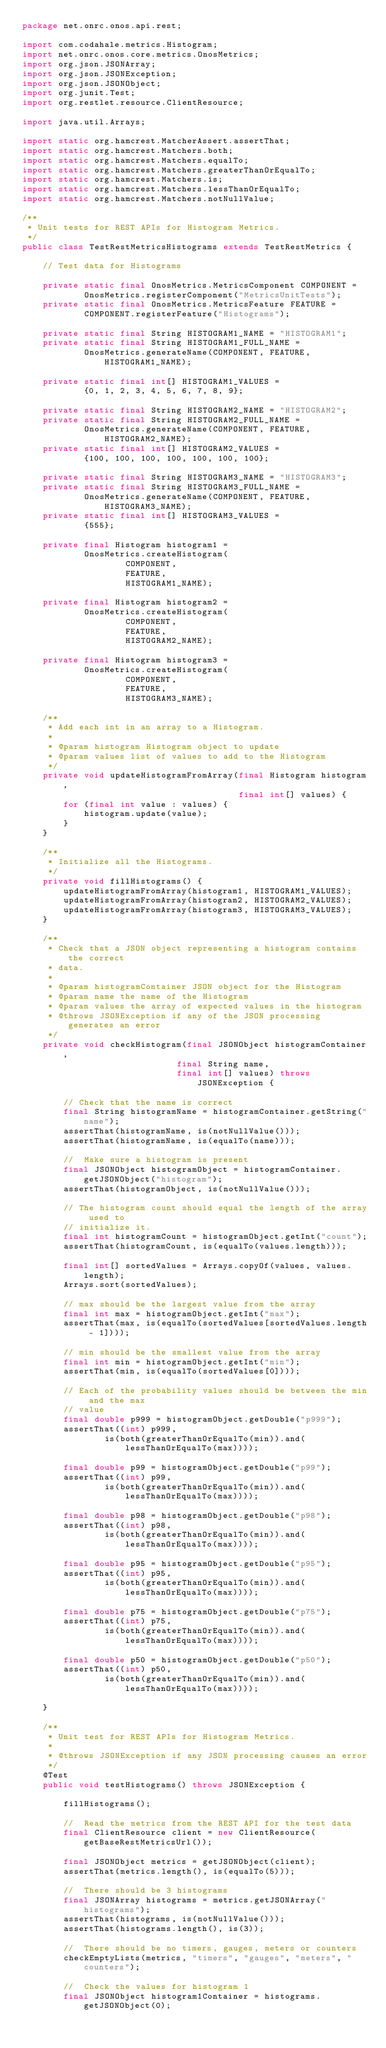<code> <loc_0><loc_0><loc_500><loc_500><_Java_>package net.onrc.onos.api.rest;

import com.codahale.metrics.Histogram;
import net.onrc.onos.core.metrics.OnosMetrics;
import org.json.JSONArray;
import org.json.JSONException;
import org.json.JSONObject;
import org.junit.Test;
import org.restlet.resource.ClientResource;

import java.util.Arrays;

import static org.hamcrest.MatcherAssert.assertThat;
import static org.hamcrest.Matchers.both;
import static org.hamcrest.Matchers.equalTo;
import static org.hamcrest.Matchers.greaterThanOrEqualTo;
import static org.hamcrest.Matchers.is;
import static org.hamcrest.Matchers.lessThanOrEqualTo;
import static org.hamcrest.Matchers.notNullValue;

/**
 * Unit tests for REST APIs for Histogram Metrics.
 */
public class TestRestMetricsHistograms extends TestRestMetrics {

    // Test data for Histograms

    private static final OnosMetrics.MetricsComponent COMPONENT =
            OnosMetrics.registerComponent("MetricsUnitTests");
    private static final OnosMetrics.MetricsFeature FEATURE =
            COMPONENT.registerFeature("Histograms");

    private static final String HISTOGRAM1_NAME = "HISTOGRAM1";
    private static final String HISTOGRAM1_FULL_NAME =
            OnosMetrics.generateName(COMPONENT, FEATURE, HISTOGRAM1_NAME);

    private static final int[] HISTOGRAM1_VALUES =
            {0, 1, 2, 3, 4, 5, 6, 7, 8, 9};

    private static final String HISTOGRAM2_NAME = "HISTOGRAM2";
    private static final String HISTOGRAM2_FULL_NAME =
            OnosMetrics.generateName(COMPONENT, FEATURE, HISTOGRAM2_NAME);
    private static final int[] HISTOGRAM2_VALUES =
            {100, 100, 100, 100, 100, 100, 100};

    private static final String HISTOGRAM3_NAME = "HISTOGRAM3";
    private static final String HISTOGRAM3_FULL_NAME =
            OnosMetrics.generateName(COMPONENT, FEATURE, HISTOGRAM3_NAME);
    private static final int[] HISTOGRAM3_VALUES =
            {555};

    private final Histogram histogram1 =
            OnosMetrics.createHistogram(
                    COMPONENT,
                    FEATURE,
                    HISTOGRAM1_NAME);

    private final Histogram histogram2 =
            OnosMetrics.createHistogram(
                    COMPONENT,
                    FEATURE,
                    HISTOGRAM2_NAME);

    private final Histogram histogram3 =
            OnosMetrics.createHistogram(
                    COMPONENT,
                    FEATURE,
                    HISTOGRAM3_NAME);

    /**
     * Add each int in an array to a Histogram.
     *
     * @param histogram Histogram object to update
     * @param values list of values to add to the Histogram
     */
    private void updateHistogramFromArray(final Histogram histogram,
                                          final int[] values) {
        for (final int value : values) {
            histogram.update(value);
        }
    }

    /**
     * Initialize all the Histograms.
     */
    private void fillHistograms() {
        updateHistogramFromArray(histogram1, HISTOGRAM1_VALUES);
        updateHistogramFromArray(histogram2, HISTOGRAM2_VALUES);
        updateHistogramFromArray(histogram3, HISTOGRAM3_VALUES);
    }

    /**
     * Check that a JSON object representing a histogram contains the correct
     * data.
     *
     * @param histogramContainer JSON object for the Histogram
     * @param name the name of the Histogram
     * @param values the array of expected values in the histogram
     * @throws JSONException if any of the JSON processing generates an error
     */
    private void checkHistogram(final JSONObject histogramContainer,
                              final String name,
                              final int[] values) throws JSONException {

        // Check that the name is correct
        final String histogramName = histogramContainer.getString("name");
        assertThat(histogramName, is(notNullValue()));
        assertThat(histogramName, is(equalTo(name)));

        //  Make sure a histogram is present
        final JSONObject histogramObject = histogramContainer.getJSONObject("histogram");
        assertThat(histogramObject, is(notNullValue()));

        // The histogram count should equal the length of the array used to
        // initialize it.
        final int histogramCount = histogramObject.getInt("count");
        assertThat(histogramCount, is(equalTo(values.length)));

        final int[] sortedValues = Arrays.copyOf(values, values.length);
        Arrays.sort(sortedValues);

        // max should be the largest value from the array
        final int max = histogramObject.getInt("max");
        assertThat(max, is(equalTo(sortedValues[sortedValues.length - 1])));

        // min should be the smallest value from the array
        final int min = histogramObject.getInt("min");
        assertThat(min, is(equalTo(sortedValues[0])));

        // Each of the probability values should be between the min and the max
        // value
        final double p999 = histogramObject.getDouble("p999");
        assertThat((int) p999,
                is(both(greaterThanOrEqualTo(min)).and(lessThanOrEqualTo(max))));

        final double p99 = histogramObject.getDouble("p99");
        assertThat((int) p99,
                is(both(greaterThanOrEqualTo(min)).and(lessThanOrEqualTo(max))));

        final double p98 = histogramObject.getDouble("p98");
        assertThat((int) p98,
                is(both(greaterThanOrEqualTo(min)).and(lessThanOrEqualTo(max))));

        final double p95 = histogramObject.getDouble("p95");
        assertThat((int) p95,
                is(both(greaterThanOrEqualTo(min)).and(lessThanOrEqualTo(max))));

        final double p75 = histogramObject.getDouble("p75");
        assertThat((int) p75,
                is(both(greaterThanOrEqualTo(min)).and(lessThanOrEqualTo(max))));

        final double p50 = histogramObject.getDouble("p50");
        assertThat((int) p50,
                is(both(greaterThanOrEqualTo(min)).and(lessThanOrEqualTo(max))));

    }

    /**
     * Unit test for REST APIs for Histogram Metrics.
     *
     * @throws JSONException if any JSON processing causes an error
     */
    @Test
    public void testHistograms() throws JSONException {

        fillHistograms();

        //  Read the metrics from the REST API for the test data
        final ClientResource client = new ClientResource(getBaseRestMetricsUrl());

        final JSONObject metrics = getJSONObject(client);
        assertThat(metrics.length(), is(equalTo(5)));

        //  There should be 3 histograms
        final JSONArray histograms = metrics.getJSONArray("histograms");
        assertThat(histograms, is(notNullValue()));
        assertThat(histograms.length(), is(3));

        //  There should be no timers, gauges, meters or counters
        checkEmptyLists(metrics, "timers", "gauges", "meters", "counters");

        //  Check the values for histogram 1
        final JSONObject histogram1Container = histograms.getJSONObject(0);</code> 